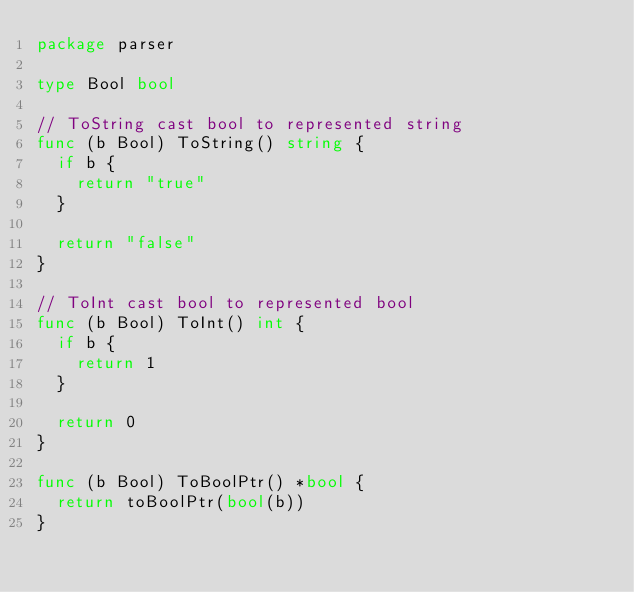Convert code to text. <code><loc_0><loc_0><loc_500><loc_500><_Go_>package parser

type Bool bool

// ToString cast bool to represented string
func (b Bool) ToString() string {
	if b {
		return "true"
	}

	return "false"
}

// ToInt cast bool to represented bool
func (b Bool) ToInt() int {
	if b {
		return 1
	}

	return 0
}

func (b Bool) ToBoolPtr() *bool {
	return toBoolPtr(bool(b))
}
</code> 